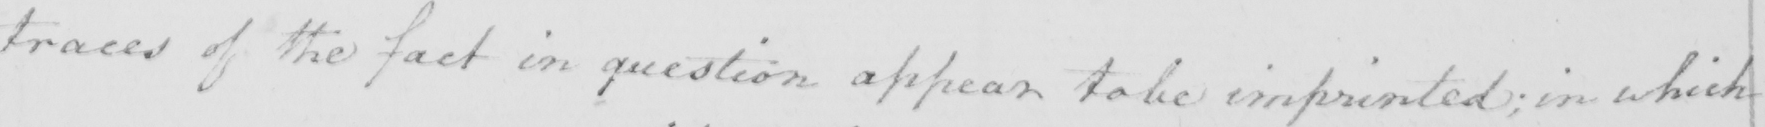What is written in this line of handwriting? traces of the fact in question appear to be imprinted ; in which 